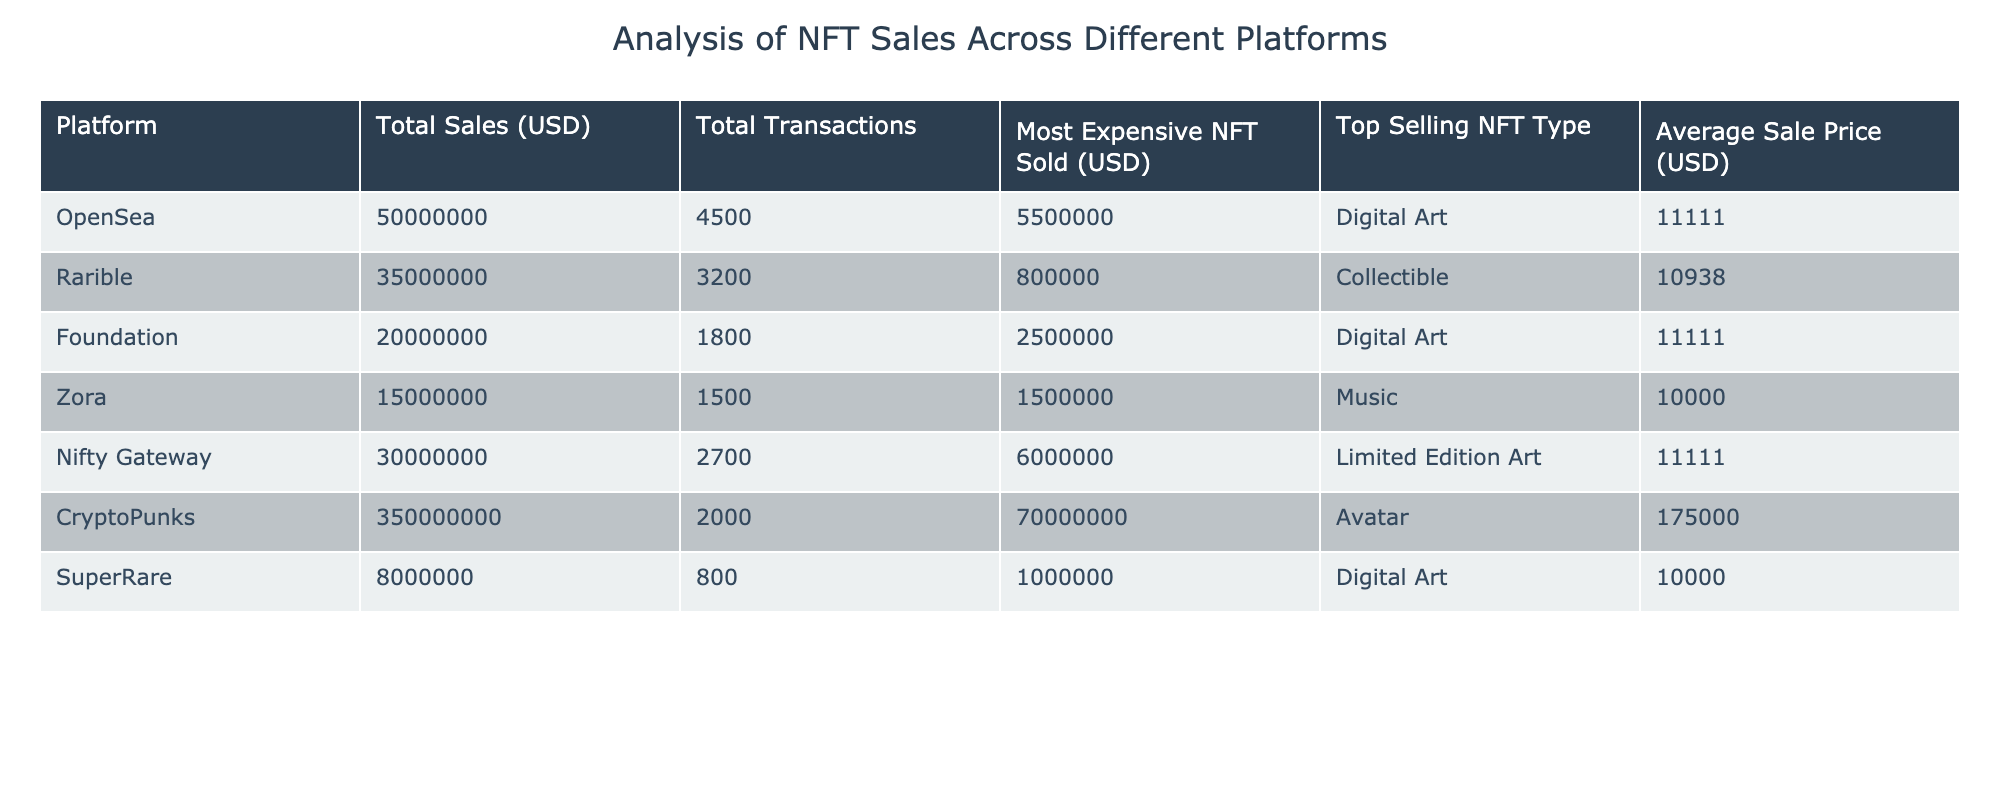What platform had the highest total sales? By looking at the 'Total Sales (USD)' column, we find that 'CryptoPunks' has the highest value at 350000000 USD.
Answer: CryptoPunks Which NFT type sold for the highest price on Rarible? Referring to the 'Most Expensive NFT Sold (USD)' column specific to Rarible, we see that it was a collectible sold for 800000 USD.
Answer: Collectible What is the average sale price across all platforms? To find the average sale price, sum the 'Average Sale Price (USD)' values (11111 + 10938 + 11111 + 10000 + 11111 + 175000 + 10000) = 307371. There are 7 platforms, so the average is 307371 / 7 = 43913.
Answer: 43913 Did SuperRare have more total sales than Zora? Comparing the 'Total Sales (USD)' values, SuperRare (8000000 USD) had less total sales than Zora (15000000 USD). Thus, the statement is false.
Answer: No What is the difference in the most expensive NFT sold between OpenSea and Foundation? The most expensive NFT sold on OpenSea is 5500000 USD and on Foundation it's 2500000 USD. The difference is 5500000 - 2500000 = 3000000 USD.
Answer: 3000000 Which platform sold the fewest total transactions? Checking the 'Total Transactions' column, SuperRare has the least transactions at 800.
Answer: SuperRare How many platforms had an average sale price of 10000 USD? By looking at the 'Average Sale Price (USD)' column, both Zora and SuperRare have an average sale price of 10000 USD, giving a total of 2 platforms.
Answer: 2 Which platform sold the most expensive NFT overall and what was its price? The 'Most Expensive NFT Sold (USD)' column shows that 'CryptoPunks' sold the most expensive NFT for 70000000 USD.
Answer: CryptoPunks, 70000000 What is the total sales value of platforms focused on digital art only? Focusing on the 'Total Sales (USD)' for platforms dealing with digital art only: OpenSea is 50000000 USD and Foundation is 20000000 USD. Total = 50000000 + 20000000 = 70000000 USD.
Answer: 70000000 